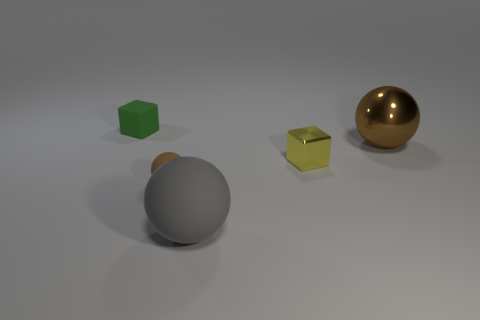Could you estimate the position of the light source based on the shadows? The shadows are falling to the right and slightly forward, indicating that the light source is to the left, above, and slightly behind the objects. 